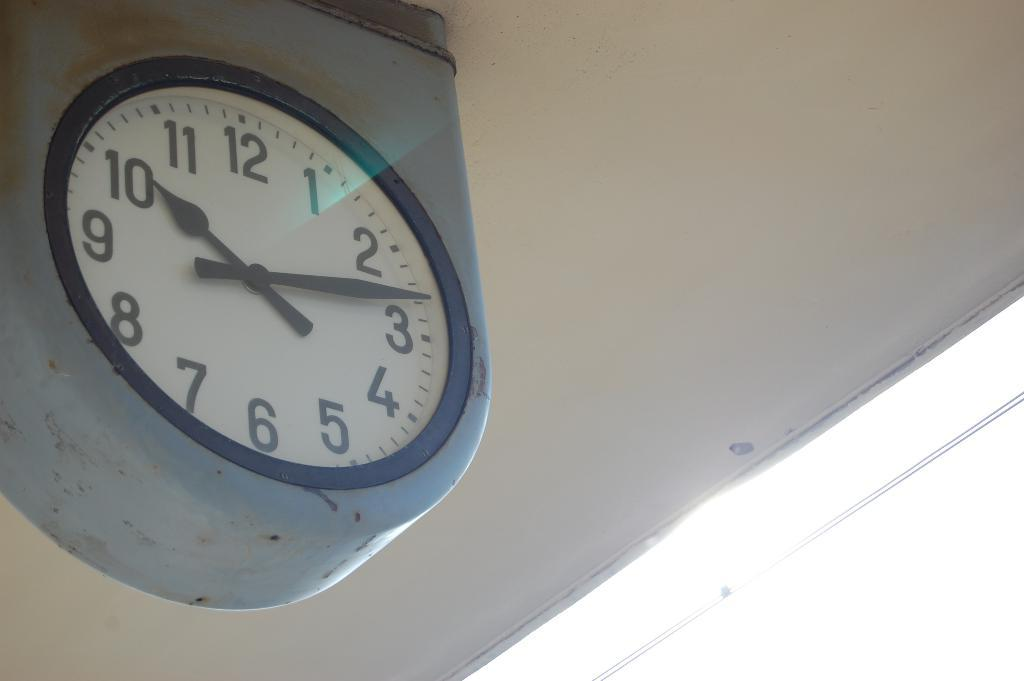<image>
Offer a succinct explanation of the picture presented. a clock with 1 through 12 on it 